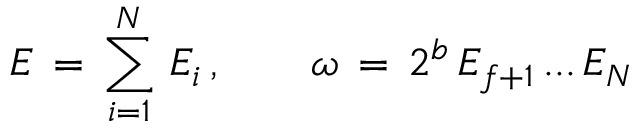<formula> <loc_0><loc_0><loc_500><loc_500>E \, = \, \sum _ { i = 1 } ^ { N } \, E _ { i } \, , \quad \omega \, = \, 2 ^ { b } \, E _ { f + 1 } \, \dots \, E _ { N }</formula> 